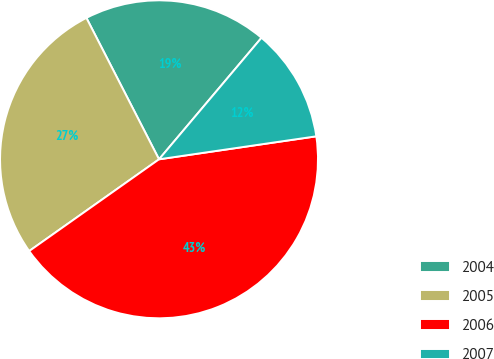Convert chart to OTSL. <chart><loc_0><loc_0><loc_500><loc_500><pie_chart><fcel>2004<fcel>2005<fcel>2006<fcel>2007<nl><fcel>18.7%<fcel>27.24%<fcel>42.52%<fcel>11.54%<nl></chart> 